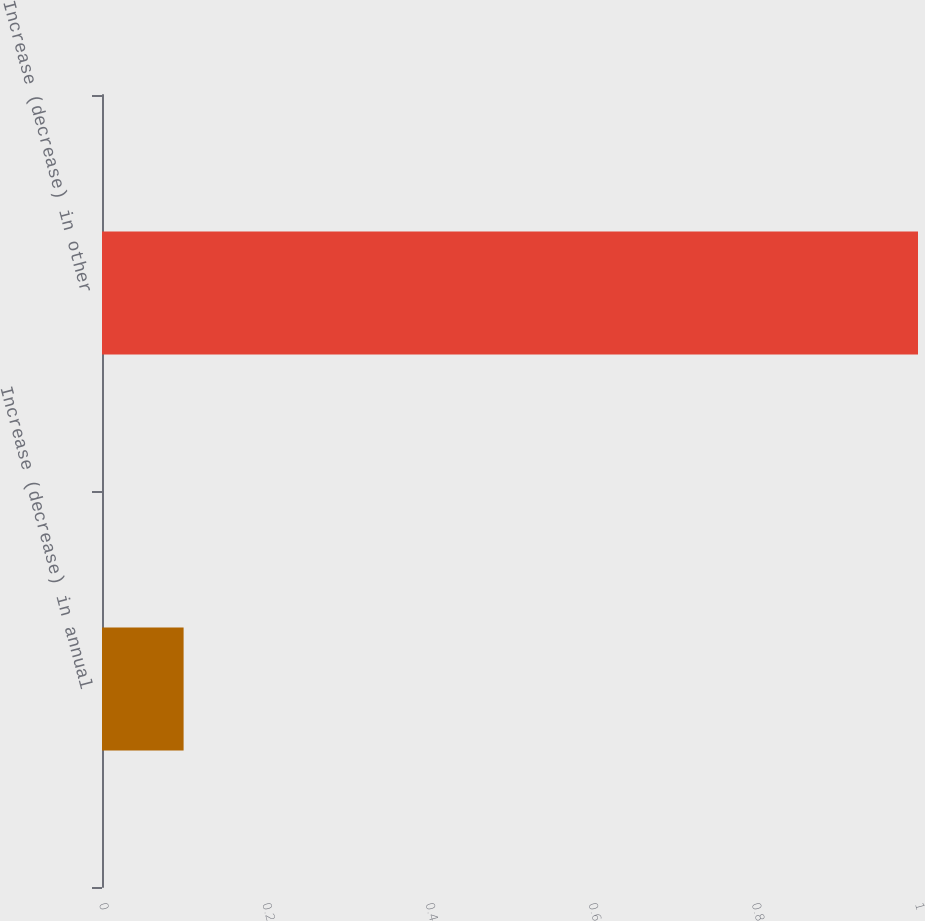<chart> <loc_0><loc_0><loc_500><loc_500><bar_chart><fcel>Increase (decrease) in annual<fcel>Increase (decrease) in other<nl><fcel>0.1<fcel>1<nl></chart> 